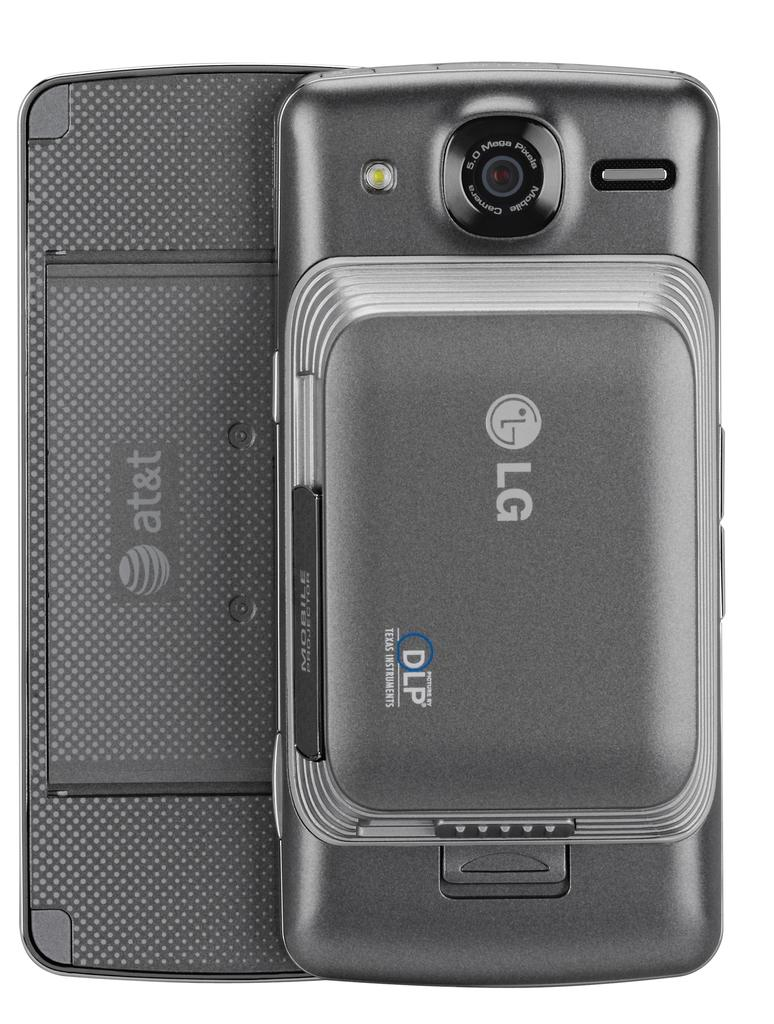What electronic device is visible in the image? There is a cell phone in the image. Where is the cell phone located in the image? The cell phone is placed on a surface. What type of pencil is being used in the lunchroom in the image? There is no pencil or lunchroom present in the image; it only features a cell phone placed on a surface. 